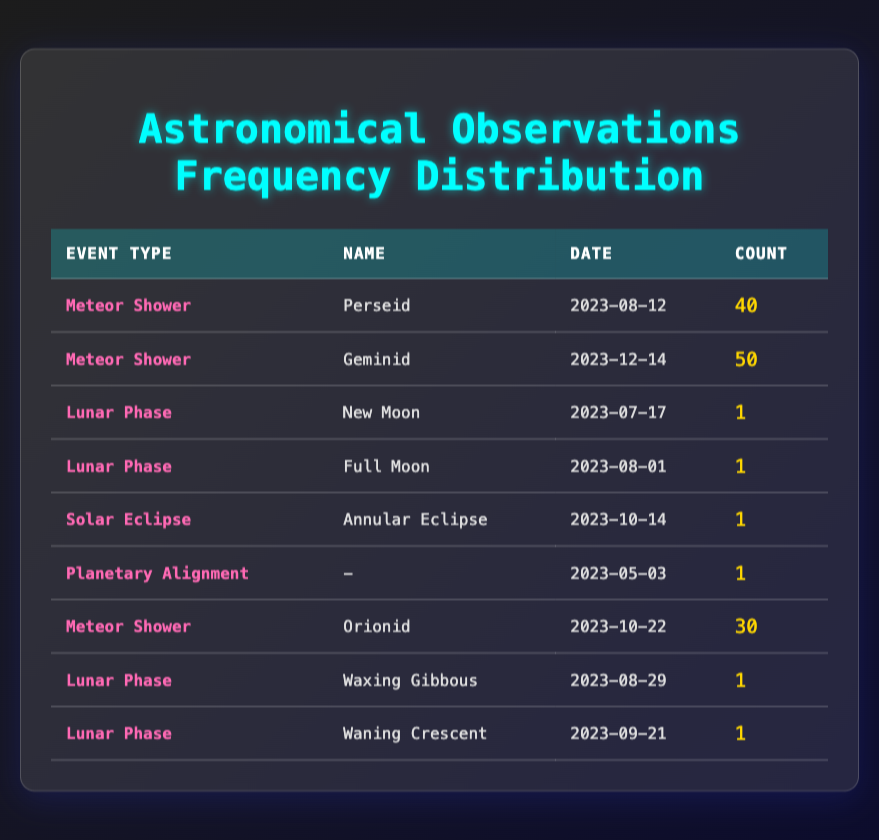What is the date of the Geminid meteor shower? The table shows that the Geminid meteor shower occurred on December 14, 2023.
Answer: December 14, 2023 How many meteor showers are documented in the table? By counting the number of entries with the event type "Meteor Shower," I see 3 instances: Perseid, Geminid, and Orionid.
Answer: 3 What is the total count of the lunar phases recorded in the journal? The journal lists four lunar phases: New Moon, Full Moon, Waxing Gibbous, and Waning Crescent. The counts for those are 1 each, so the total is 1 + 1 + 1 + 1 = 4.
Answer: 4 Was there a solar eclipse documented? The entry for the solar eclipse indicates that an Annular Eclipse was documented on October 14, 2023, thus affirming that there was a solar eclipse.
Answer: Yes Which event has the highest count in the observations? The table indicates that the Geminid meteor shower has the highest count of 50, which is higher than the others listed.
Answer: Geminid meteor shower Calculate the average count of all the recorded events. To find the average, I will sum the counts: 40 + 50 + 1 + 1 + 1 + 1 + 30 + 1 + 1 = 126. There are 9 events, so the average is 126 / 9 = 14.
Answer: 14 How many different types of events are recorded in the table? The events listed include Meteor Showers, Lunar Phases, a Solar Eclipse, and Planetary Alignment, totaling to four distinct event types.
Answer: 4 Is the count of the Orionid meteor shower more than the count of lunar phases recorded? The count for the Orionid meteor shower is 30, while the total count for lunar phases is 4, which means the Orionid count is greater.
Answer: Yes Which lunar phase occurred on August 29, 2023? The table indicates that the event recorded on August 29, 2023, is Waxing Gibbous, which is a type of lunar phase.
Answer: Waxing Gibbous 